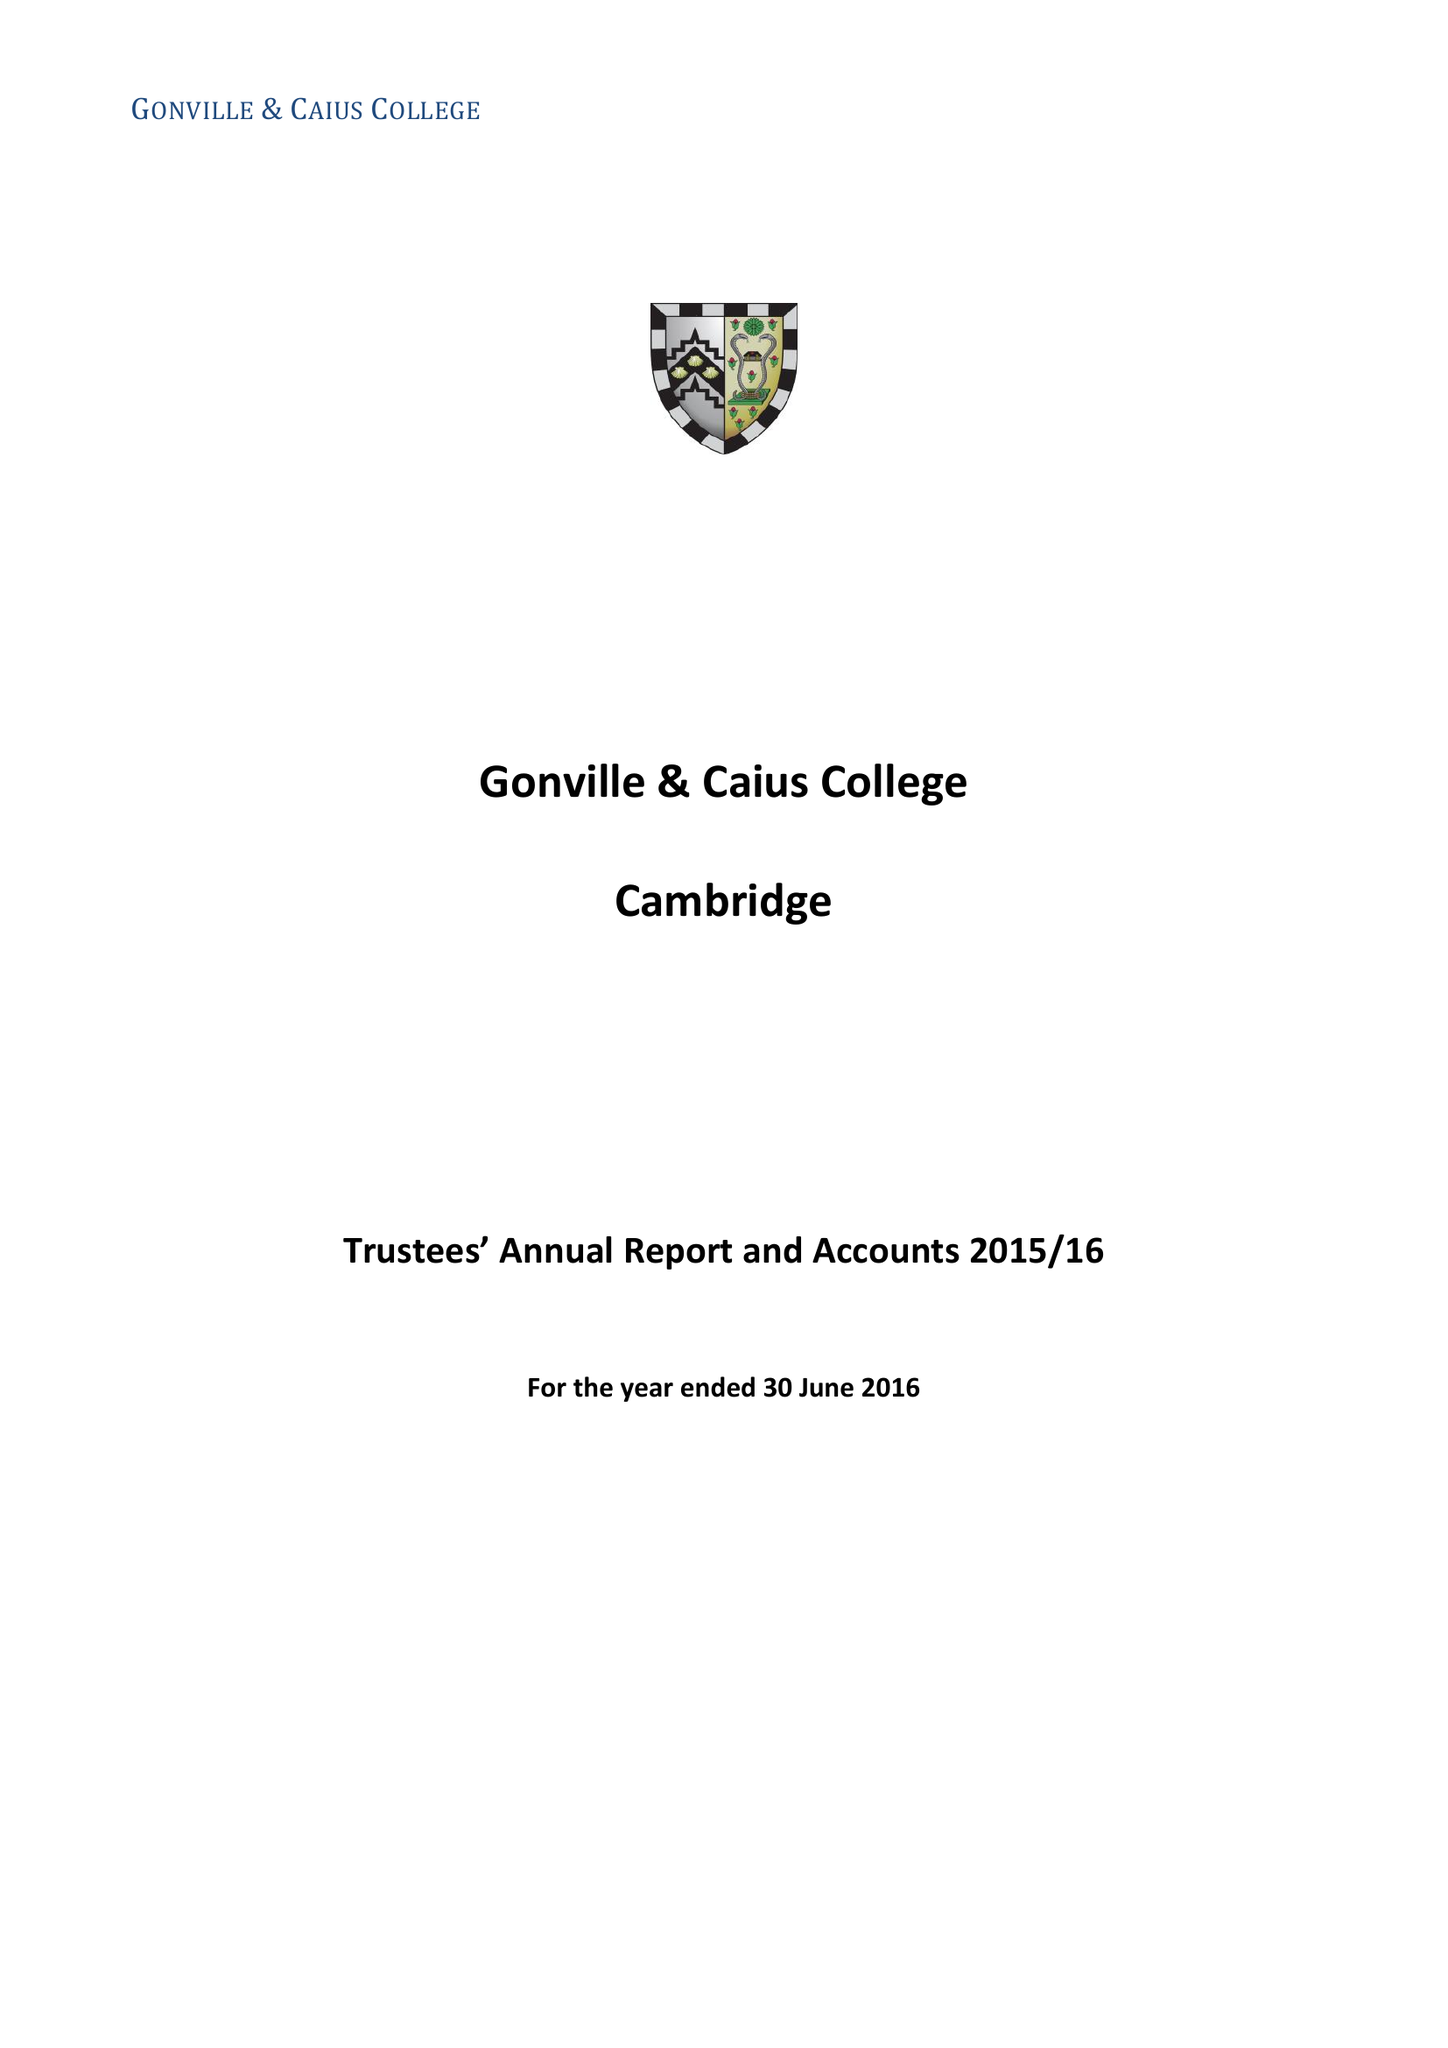What is the value for the charity_name?
Answer the question using a single word or phrase. Gonville and Caius College 